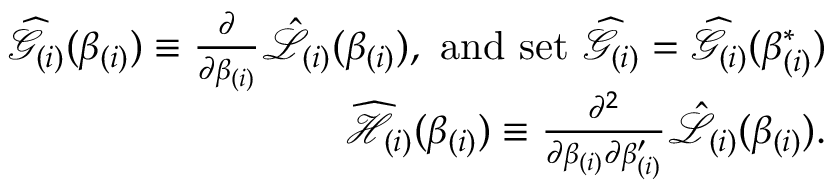<formula> <loc_0><loc_0><loc_500><loc_500>\begin{array} { r l r } & { \widehat { \mathcal { G } } _ { ( i ) } ( \beta _ { ( i ) } ) \equiv \frac { \partial } { \partial \beta _ { ( i ) } } \mathcal { \hat { L } } _ { ( i ) } ( \beta _ { ( i ) } ) , a n d s e t \ \widehat { \mathcal { G } } _ { ( i ) } = \widehat { \mathcal { G } } _ { ( i ) } ( \beta _ { ( i ) } ^ { \ast } ) } \\ & { \widehat { \mathcal { H } } _ { ( i ) } ( \beta _ { ( i ) } ) \equiv \frac { \partial ^ { 2 } } { \partial \beta _ { ( i ) } \partial \beta _ { ( i ) } ^ { \prime } } \mathcal { \hat { L } } _ { ( i ) } ( \beta _ { ( i ) } ) . } \end{array}</formula> 